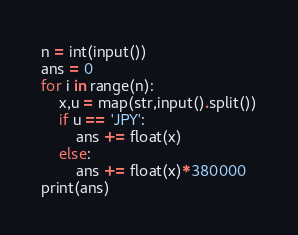Convert code to text. <code><loc_0><loc_0><loc_500><loc_500><_Python_>n = int(input())
ans = 0
for i in range(n):
    x,u = map(str,input().split())
    if u == 'JPY':
        ans += float(x)
    else:
        ans += float(x)*380000
print(ans) </code> 